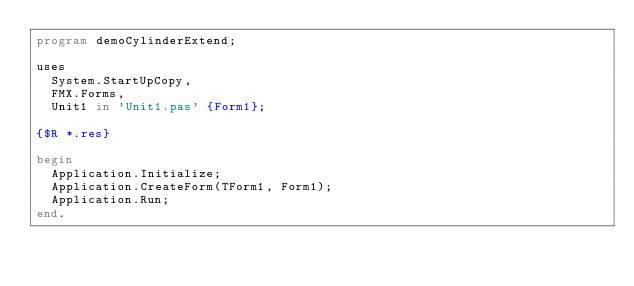Convert code to text. <code><loc_0><loc_0><loc_500><loc_500><_Pascal_>program demoCylinderExtend;

uses
  System.StartUpCopy,
  FMX.Forms,
  Unit1 in 'Unit1.pas' {Form1};

{$R *.res}

begin
  Application.Initialize;
  Application.CreateForm(TForm1, Form1);
  Application.Run;
end.
</code> 